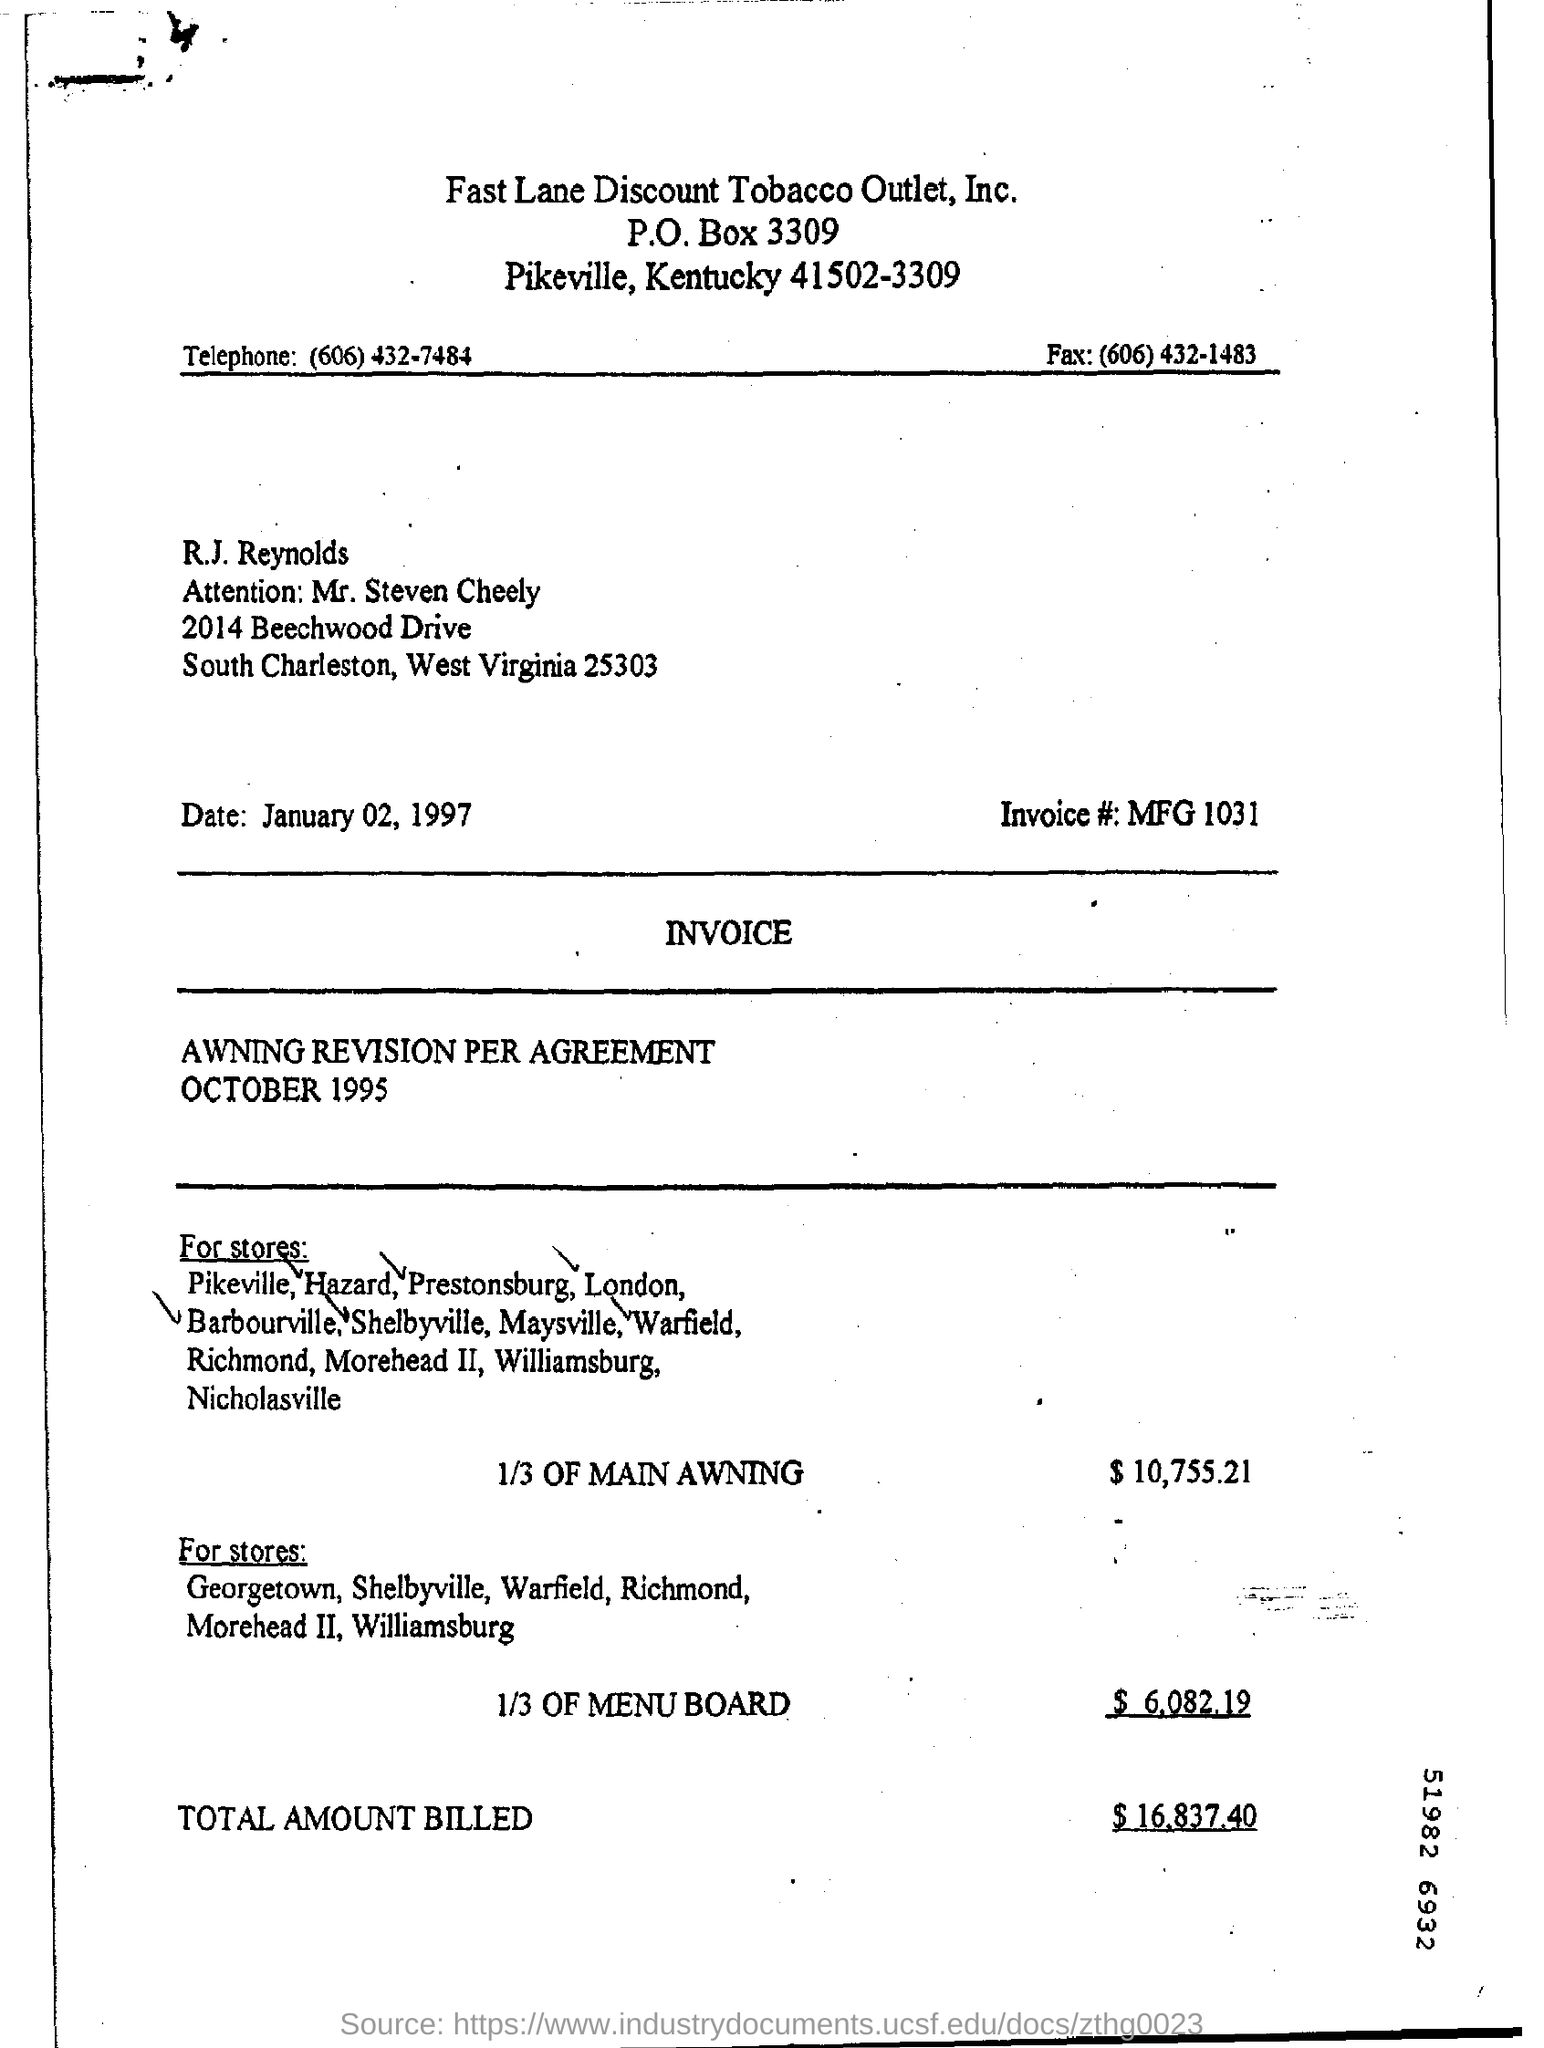What is the date of the invoice ?
Give a very brief answer. January 02,1997. What is the invoice# number ?
Your response must be concise. MFG 1031. What is the telephone number ?
Ensure brevity in your answer.  (606) 432-7484. What is the fax number of the tobacco outlet?
Provide a succinct answer. (606) 432-1483. What is the total amount billed ?
Provide a succinct answer. $ 16,837.40. Which tobacco outlet's letterhead is this?
Your answer should be very brief. Fast Lane Discount Tobacco Outlet, Inc. What is the amount for 1/3 of menu board ?
Provide a succinct answer. $6,082.19. 